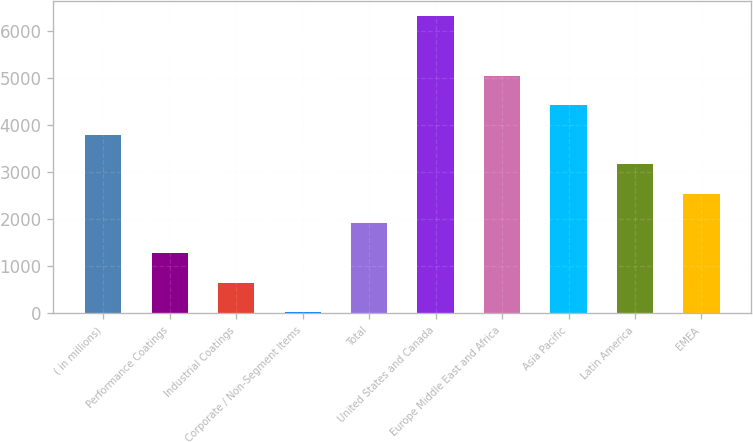Convert chart to OTSL. <chart><loc_0><loc_0><loc_500><loc_500><bar_chart><fcel>( in millions)<fcel>Performance Coatings<fcel>Industrial Coatings<fcel>Corporate / Non-Segment Items<fcel>Total<fcel>United States and Canada<fcel>Europe Middle East and Africa<fcel>Asia Pacific<fcel>Latin America<fcel>EMEA<nl><fcel>3793.8<fcel>1280.6<fcel>652.3<fcel>24<fcel>1908.9<fcel>6307<fcel>5050.4<fcel>4422.1<fcel>3165.5<fcel>2537.2<nl></chart> 